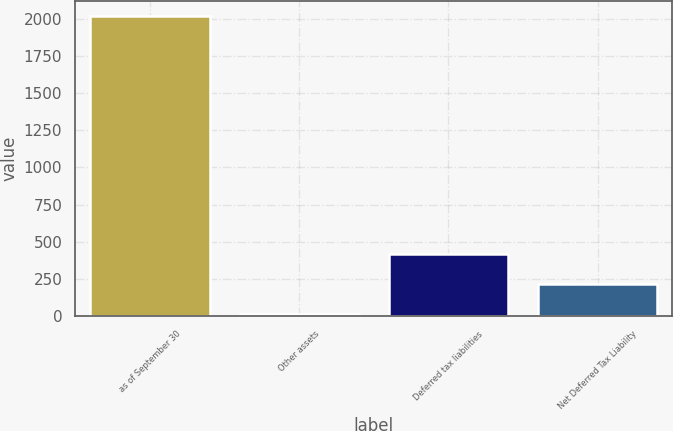Convert chart. <chart><loc_0><loc_0><loc_500><loc_500><bar_chart><fcel>as of September 30<fcel>Other assets<fcel>Deferred tax liabilities<fcel>Net Deferred Tax Liability<nl><fcel>2018<fcel>17.3<fcel>417.44<fcel>217.37<nl></chart> 